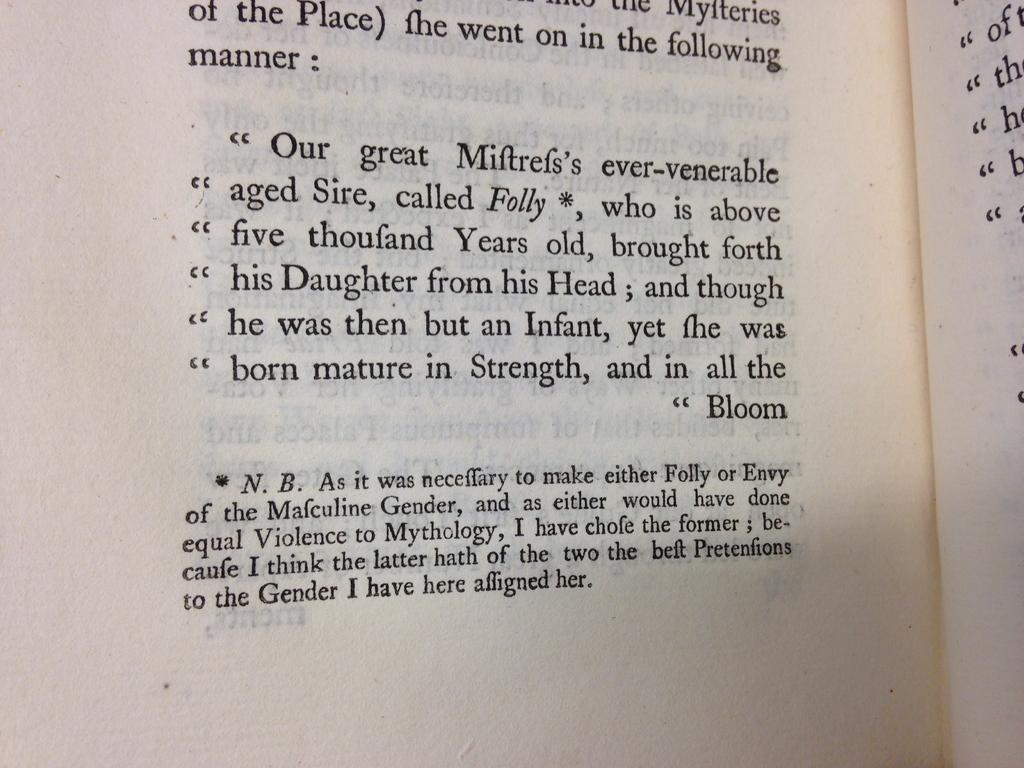<image>
Describe the image concisely. A section of this book page about Folly requires a footnote explaining gender choices. 